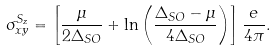<formula> <loc_0><loc_0><loc_500><loc_500>\sigma ^ { S _ { z } } _ { x y } = \left [ \frac { \mu } { 2 \Delta _ { S O } } + \ln \left ( \frac { \Delta _ { S O } - \mu } { 4 \Delta _ { S O } } \right ) \right ] \frac { e } { 4 \pi } .</formula> 